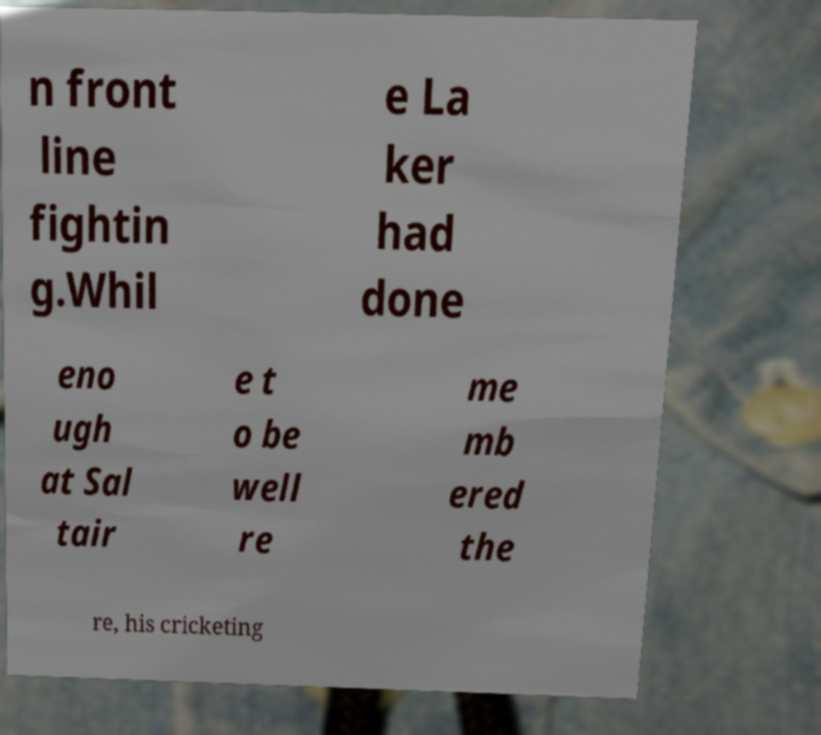There's text embedded in this image that I need extracted. Can you transcribe it verbatim? n front line fightin g.Whil e La ker had done eno ugh at Sal tair e t o be well re me mb ered the re, his cricketing 